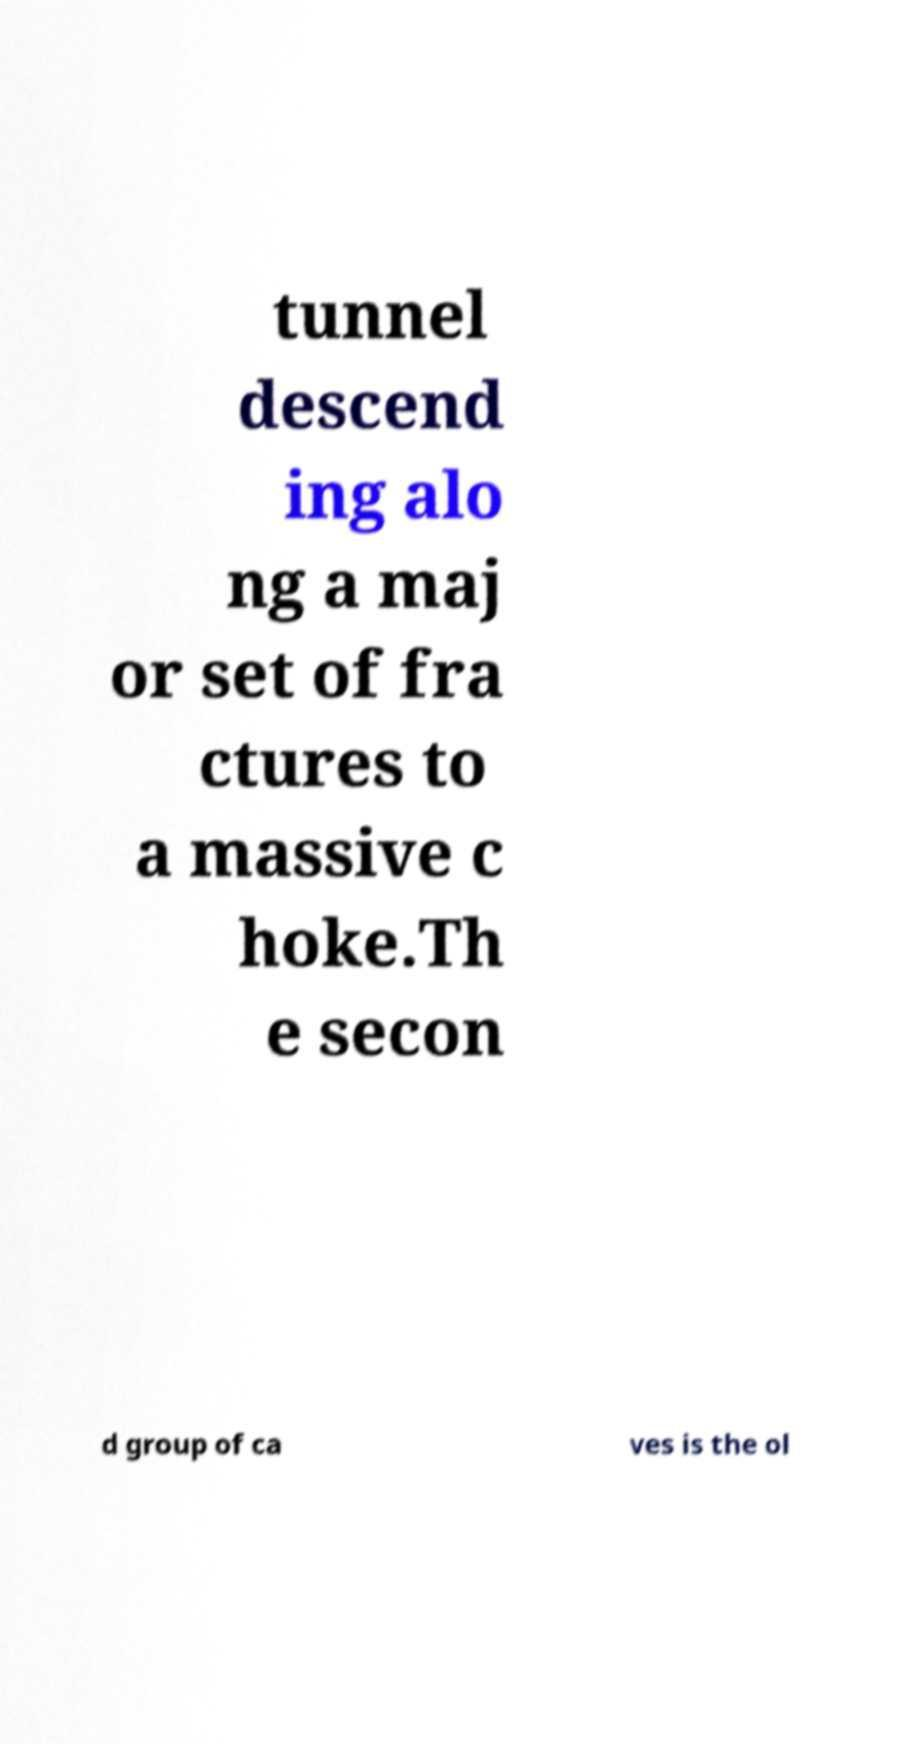There's text embedded in this image that I need extracted. Can you transcribe it verbatim? tunnel descend ing alo ng a maj or set of fra ctures to a massive c hoke.Th e secon d group of ca ves is the ol 